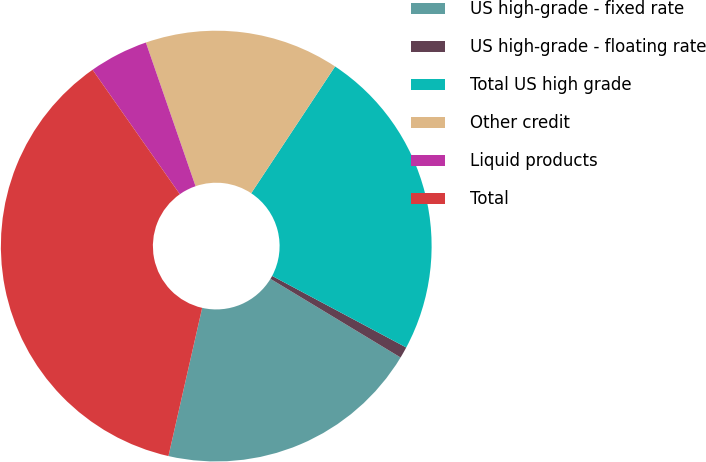Convert chart. <chart><loc_0><loc_0><loc_500><loc_500><pie_chart><fcel>US high-grade - fixed rate<fcel>US high-grade - floating rate<fcel>Total US high grade<fcel>Other credit<fcel>Liquid products<fcel>Total<nl><fcel>19.91%<fcel>0.85%<fcel>23.5%<fcel>14.6%<fcel>4.44%<fcel>36.7%<nl></chart> 